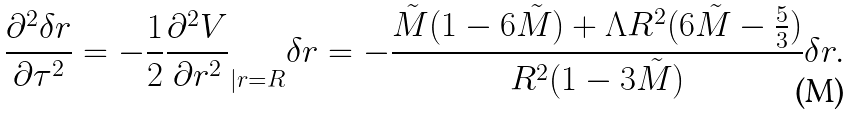<formula> <loc_0><loc_0><loc_500><loc_500>\frac { \partial ^ { 2 } \delta r } { \partial \tau ^ { 2 } } = - \frac { 1 } { 2 } \frac { \partial ^ { 2 } V } { \partial r ^ { 2 } } _ { | r = R } \delta r = - \frac { \tilde { M } ( 1 - 6 \tilde { M } ) + \Lambda R ^ { 2 } ( 6 \tilde { M } - \frac { 5 } { 3 } ) } { R ^ { 2 } ( 1 - 3 \tilde { M } ) } \delta r .</formula> 